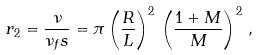<formula> <loc_0><loc_0><loc_500><loc_500>r _ { 2 } = \frac { \nu } { \nu _ { f } s } = \pi \left ( \frac { R } { L } \right ) ^ { 2 } \, \left ( \frac { 1 + M } { M } \right ) ^ { 2 } \, ,</formula> 